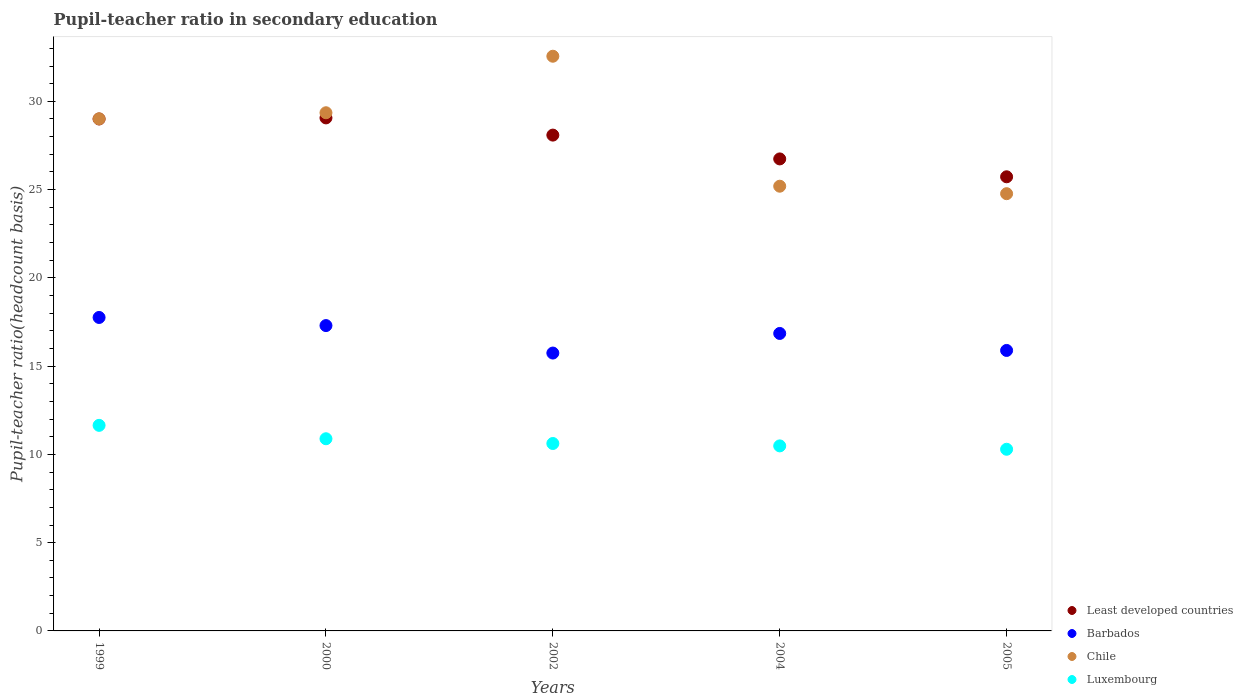How many different coloured dotlines are there?
Make the answer very short. 4. Is the number of dotlines equal to the number of legend labels?
Give a very brief answer. Yes. What is the pupil-teacher ratio in secondary education in Luxembourg in 2005?
Your response must be concise. 10.29. Across all years, what is the maximum pupil-teacher ratio in secondary education in Luxembourg?
Your response must be concise. 11.65. Across all years, what is the minimum pupil-teacher ratio in secondary education in Barbados?
Offer a terse response. 15.74. In which year was the pupil-teacher ratio in secondary education in Chile maximum?
Provide a succinct answer. 2002. In which year was the pupil-teacher ratio in secondary education in Least developed countries minimum?
Keep it short and to the point. 2005. What is the total pupil-teacher ratio in secondary education in Least developed countries in the graph?
Offer a terse response. 138.61. What is the difference between the pupil-teacher ratio in secondary education in Luxembourg in 1999 and that in 2004?
Offer a very short reply. 1.16. What is the difference between the pupil-teacher ratio in secondary education in Chile in 1999 and the pupil-teacher ratio in secondary education in Luxembourg in 2005?
Keep it short and to the point. 18.72. What is the average pupil-teacher ratio in secondary education in Chile per year?
Provide a short and direct response. 28.18. In the year 2002, what is the difference between the pupil-teacher ratio in secondary education in Luxembourg and pupil-teacher ratio in secondary education in Chile?
Provide a short and direct response. -21.94. What is the ratio of the pupil-teacher ratio in secondary education in Chile in 2002 to that in 2005?
Your response must be concise. 1.31. Is the pupil-teacher ratio in secondary education in Least developed countries in 1999 less than that in 2004?
Keep it short and to the point. No. Is the difference between the pupil-teacher ratio in secondary education in Luxembourg in 1999 and 2004 greater than the difference between the pupil-teacher ratio in secondary education in Chile in 1999 and 2004?
Provide a succinct answer. No. What is the difference between the highest and the second highest pupil-teacher ratio in secondary education in Barbados?
Offer a terse response. 0.46. What is the difference between the highest and the lowest pupil-teacher ratio in secondary education in Chile?
Keep it short and to the point. 7.79. In how many years, is the pupil-teacher ratio in secondary education in Luxembourg greater than the average pupil-teacher ratio in secondary education in Luxembourg taken over all years?
Make the answer very short. 2. Is the sum of the pupil-teacher ratio in secondary education in Least developed countries in 1999 and 2004 greater than the maximum pupil-teacher ratio in secondary education in Luxembourg across all years?
Ensure brevity in your answer.  Yes. Is it the case that in every year, the sum of the pupil-teacher ratio in secondary education in Chile and pupil-teacher ratio in secondary education in Barbados  is greater than the sum of pupil-teacher ratio in secondary education in Luxembourg and pupil-teacher ratio in secondary education in Least developed countries?
Make the answer very short. No. Is it the case that in every year, the sum of the pupil-teacher ratio in secondary education in Chile and pupil-teacher ratio in secondary education in Luxembourg  is greater than the pupil-teacher ratio in secondary education in Least developed countries?
Your answer should be very brief. Yes. Does the pupil-teacher ratio in secondary education in Chile monotonically increase over the years?
Your answer should be very brief. No. Is the pupil-teacher ratio in secondary education in Barbados strictly greater than the pupil-teacher ratio in secondary education in Chile over the years?
Provide a succinct answer. No. Is the pupil-teacher ratio in secondary education in Barbados strictly less than the pupil-teacher ratio in secondary education in Least developed countries over the years?
Your answer should be very brief. Yes. How many dotlines are there?
Give a very brief answer. 4. What is the difference between two consecutive major ticks on the Y-axis?
Offer a very short reply. 5. Does the graph contain grids?
Provide a short and direct response. No. Where does the legend appear in the graph?
Your answer should be compact. Bottom right. What is the title of the graph?
Give a very brief answer. Pupil-teacher ratio in secondary education. Does "Chad" appear as one of the legend labels in the graph?
Ensure brevity in your answer.  No. What is the label or title of the Y-axis?
Provide a short and direct response. Pupil-teacher ratio(headcount basis). What is the Pupil-teacher ratio(headcount basis) in Least developed countries in 1999?
Offer a terse response. 29. What is the Pupil-teacher ratio(headcount basis) in Barbados in 1999?
Keep it short and to the point. 17.76. What is the Pupil-teacher ratio(headcount basis) of Chile in 1999?
Your answer should be compact. 29.01. What is the Pupil-teacher ratio(headcount basis) of Luxembourg in 1999?
Offer a terse response. 11.65. What is the Pupil-teacher ratio(headcount basis) of Least developed countries in 2000?
Offer a very short reply. 29.06. What is the Pupil-teacher ratio(headcount basis) in Barbados in 2000?
Your answer should be very brief. 17.3. What is the Pupil-teacher ratio(headcount basis) of Chile in 2000?
Make the answer very short. 29.35. What is the Pupil-teacher ratio(headcount basis) of Luxembourg in 2000?
Your answer should be compact. 10.89. What is the Pupil-teacher ratio(headcount basis) of Least developed countries in 2002?
Give a very brief answer. 28.09. What is the Pupil-teacher ratio(headcount basis) of Barbados in 2002?
Keep it short and to the point. 15.74. What is the Pupil-teacher ratio(headcount basis) in Chile in 2002?
Offer a very short reply. 32.56. What is the Pupil-teacher ratio(headcount basis) of Luxembourg in 2002?
Offer a very short reply. 10.62. What is the Pupil-teacher ratio(headcount basis) of Least developed countries in 2004?
Offer a terse response. 26.74. What is the Pupil-teacher ratio(headcount basis) in Barbados in 2004?
Your response must be concise. 16.85. What is the Pupil-teacher ratio(headcount basis) of Chile in 2004?
Give a very brief answer. 25.19. What is the Pupil-teacher ratio(headcount basis) in Luxembourg in 2004?
Give a very brief answer. 10.48. What is the Pupil-teacher ratio(headcount basis) in Least developed countries in 2005?
Offer a terse response. 25.73. What is the Pupil-teacher ratio(headcount basis) in Barbados in 2005?
Offer a terse response. 15.89. What is the Pupil-teacher ratio(headcount basis) of Chile in 2005?
Offer a very short reply. 24.77. What is the Pupil-teacher ratio(headcount basis) in Luxembourg in 2005?
Your answer should be compact. 10.29. Across all years, what is the maximum Pupil-teacher ratio(headcount basis) of Least developed countries?
Provide a succinct answer. 29.06. Across all years, what is the maximum Pupil-teacher ratio(headcount basis) of Barbados?
Offer a very short reply. 17.76. Across all years, what is the maximum Pupil-teacher ratio(headcount basis) of Chile?
Provide a short and direct response. 32.56. Across all years, what is the maximum Pupil-teacher ratio(headcount basis) of Luxembourg?
Ensure brevity in your answer.  11.65. Across all years, what is the minimum Pupil-teacher ratio(headcount basis) in Least developed countries?
Offer a very short reply. 25.73. Across all years, what is the minimum Pupil-teacher ratio(headcount basis) of Barbados?
Provide a short and direct response. 15.74. Across all years, what is the minimum Pupil-teacher ratio(headcount basis) of Chile?
Ensure brevity in your answer.  24.77. Across all years, what is the minimum Pupil-teacher ratio(headcount basis) in Luxembourg?
Make the answer very short. 10.29. What is the total Pupil-teacher ratio(headcount basis) of Least developed countries in the graph?
Your answer should be compact. 138.61. What is the total Pupil-teacher ratio(headcount basis) in Barbados in the graph?
Give a very brief answer. 83.53. What is the total Pupil-teacher ratio(headcount basis) of Chile in the graph?
Keep it short and to the point. 140.88. What is the total Pupil-teacher ratio(headcount basis) of Luxembourg in the graph?
Provide a short and direct response. 53.92. What is the difference between the Pupil-teacher ratio(headcount basis) of Least developed countries in 1999 and that in 2000?
Offer a very short reply. -0.06. What is the difference between the Pupil-teacher ratio(headcount basis) in Barbados in 1999 and that in 2000?
Your response must be concise. 0.46. What is the difference between the Pupil-teacher ratio(headcount basis) in Chile in 1999 and that in 2000?
Make the answer very short. -0.34. What is the difference between the Pupil-teacher ratio(headcount basis) of Luxembourg in 1999 and that in 2000?
Your response must be concise. 0.76. What is the difference between the Pupil-teacher ratio(headcount basis) of Least developed countries in 1999 and that in 2002?
Your answer should be very brief. 0.91. What is the difference between the Pupil-teacher ratio(headcount basis) in Barbados in 1999 and that in 2002?
Provide a short and direct response. 2.02. What is the difference between the Pupil-teacher ratio(headcount basis) in Chile in 1999 and that in 2002?
Your answer should be very brief. -3.55. What is the difference between the Pupil-teacher ratio(headcount basis) in Luxembourg in 1999 and that in 2002?
Give a very brief answer. 1.03. What is the difference between the Pupil-teacher ratio(headcount basis) of Least developed countries in 1999 and that in 2004?
Your answer should be compact. 2.26. What is the difference between the Pupil-teacher ratio(headcount basis) in Barbados in 1999 and that in 2004?
Keep it short and to the point. 0.91. What is the difference between the Pupil-teacher ratio(headcount basis) of Chile in 1999 and that in 2004?
Make the answer very short. 3.82. What is the difference between the Pupil-teacher ratio(headcount basis) of Luxembourg in 1999 and that in 2004?
Ensure brevity in your answer.  1.16. What is the difference between the Pupil-teacher ratio(headcount basis) in Least developed countries in 1999 and that in 2005?
Your answer should be very brief. 3.28. What is the difference between the Pupil-teacher ratio(headcount basis) in Barbados in 1999 and that in 2005?
Your answer should be very brief. 1.87. What is the difference between the Pupil-teacher ratio(headcount basis) of Chile in 1999 and that in 2005?
Your response must be concise. 4.24. What is the difference between the Pupil-teacher ratio(headcount basis) of Luxembourg in 1999 and that in 2005?
Keep it short and to the point. 1.35. What is the difference between the Pupil-teacher ratio(headcount basis) in Least developed countries in 2000 and that in 2002?
Give a very brief answer. 0.97. What is the difference between the Pupil-teacher ratio(headcount basis) of Barbados in 2000 and that in 2002?
Offer a terse response. 1.56. What is the difference between the Pupil-teacher ratio(headcount basis) in Chile in 2000 and that in 2002?
Keep it short and to the point. -3.2. What is the difference between the Pupil-teacher ratio(headcount basis) of Luxembourg in 2000 and that in 2002?
Ensure brevity in your answer.  0.27. What is the difference between the Pupil-teacher ratio(headcount basis) of Least developed countries in 2000 and that in 2004?
Offer a very short reply. 2.32. What is the difference between the Pupil-teacher ratio(headcount basis) in Barbados in 2000 and that in 2004?
Your answer should be compact. 0.45. What is the difference between the Pupil-teacher ratio(headcount basis) in Chile in 2000 and that in 2004?
Ensure brevity in your answer.  4.16. What is the difference between the Pupil-teacher ratio(headcount basis) in Luxembourg in 2000 and that in 2004?
Give a very brief answer. 0.4. What is the difference between the Pupil-teacher ratio(headcount basis) of Least developed countries in 2000 and that in 2005?
Your response must be concise. 3.34. What is the difference between the Pupil-teacher ratio(headcount basis) of Barbados in 2000 and that in 2005?
Your response must be concise. 1.41. What is the difference between the Pupil-teacher ratio(headcount basis) of Chile in 2000 and that in 2005?
Ensure brevity in your answer.  4.58. What is the difference between the Pupil-teacher ratio(headcount basis) of Luxembourg in 2000 and that in 2005?
Make the answer very short. 0.6. What is the difference between the Pupil-teacher ratio(headcount basis) of Least developed countries in 2002 and that in 2004?
Ensure brevity in your answer.  1.35. What is the difference between the Pupil-teacher ratio(headcount basis) in Barbados in 2002 and that in 2004?
Your response must be concise. -1.11. What is the difference between the Pupil-teacher ratio(headcount basis) of Chile in 2002 and that in 2004?
Ensure brevity in your answer.  7.36. What is the difference between the Pupil-teacher ratio(headcount basis) in Luxembourg in 2002 and that in 2004?
Your response must be concise. 0.14. What is the difference between the Pupil-teacher ratio(headcount basis) of Least developed countries in 2002 and that in 2005?
Ensure brevity in your answer.  2.36. What is the difference between the Pupil-teacher ratio(headcount basis) of Barbados in 2002 and that in 2005?
Your answer should be very brief. -0.15. What is the difference between the Pupil-teacher ratio(headcount basis) of Chile in 2002 and that in 2005?
Your answer should be compact. 7.79. What is the difference between the Pupil-teacher ratio(headcount basis) in Luxembourg in 2002 and that in 2005?
Make the answer very short. 0.33. What is the difference between the Pupil-teacher ratio(headcount basis) in Least developed countries in 2004 and that in 2005?
Offer a terse response. 1.01. What is the difference between the Pupil-teacher ratio(headcount basis) of Barbados in 2004 and that in 2005?
Your answer should be compact. 0.96. What is the difference between the Pupil-teacher ratio(headcount basis) of Chile in 2004 and that in 2005?
Make the answer very short. 0.42. What is the difference between the Pupil-teacher ratio(headcount basis) in Luxembourg in 2004 and that in 2005?
Your answer should be compact. 0.19. What is the difference between the Pupil-teacher ratio(headcount basis) in Least developed countries in 1999 and the Pupil-teacher ratio(headcount basis) in Barbados in 2000?
Offer a very short reply. 11.7. What is the difference between the Pupil-teacher ratio(headcount basis) in Least developed countries in 1999 and the Pupil-teacher ratio(headcount basis) in Chile in 2000?
Your answer should be compact. -0.35. What is the difference between the Pupil-teacher ratio(headcount basis) of Least developed countries in 1999 and the Pupil-teacher ratio(headcount basis) of Luxembourg in 2000?
Provide a succinct answer. 18.11. What is the difference between the Pupil-teacher ratio(headcount basis) in Barbados in 1999 and the Pupil-teacher ratio(headcount basis) in Chile in 2000?
Keep it short and to the point. -11.6. What is the difference between the Pupil-teacher ratio(headcount basis) in Barbados in 1999 and the Pupil-teacher ratio(headcount basis) in Luxembourg in 2000?
Your answer should be compact. 6.87. What is the difference between the Pupil-teacher ratio(headcount basis) in Chile in 1999 and the Pupil-teacher ratio(headcount basis) in Luxembourg in 2000?
Offer a terse response. 18.12. What is the difference between the Pupil-teacher ratio(headcount basis) in Least developed countries in 1999 and the Pupil-teacher ratio(headcount basis) in Barbados in 2002?
Ensure brevity in your answer.  13.26. What is the difference between the Pupil-teacher ratio(headcount basis) in Least developed countries in 1999 and the Pupil-teacher ratio(headcount basis) in Chile in 2002?
Your answer should be compact. -3.55. What is the difference between the Pupil-teacher ratio(headcount basis) in Least developed countries in 1999 and the Pupil-teacher ratio(headcount basis) in Luxembourg in 2002?
Ensure brevity in your answer.  18.38. What is the difference between the Pupil-teacher ratio(headcount basis) of Barbados in 1999 and the Pupil-teacher ratio(headcount basis) of Chile in 2002?
Your answer should be compact. -14.8. What is the difference between the Pupil-teacher ratio(headcount basis) of Barbados in 1999 and the Pupil-teacher ratio(headcount basis) of Luxembourg in 2002?
Provide a short and direct response. 7.14. What is the difference between the Pupil-teacher ratio(headcount basis) of Chile in 1999 and the Pupil-teacher ratio(headcount basis) of Luxembourg in 2002?
Your answer should be compact. 18.39. What is the difference between the Pupil-teacher ratio(headcount basis) of Least developed countries in 1999 and the Pupil-teacher ratio(headcount basis) of Barbados in 2004?
Your answer should be compact. 12.15. What is the difference between the Pupil-teacher ratio(headcount basis) in Least developed countries in 1999 and the Pupil-teacher ratio(headcount basis) in Chile in 2004?
Keep it short and to the point. 3.81. What is the difference between the Pupil-teacher ratio(headcount basis) of Least developed countries in 1999 and the Pupil-teacher ratio(headcount basis) of Luxembourg in 2004?
Keep it short and to the point. 18.52. What is the difference between the Pupil-teacher ratio(headcount basis) in Barbados in 1999 and the Pupil-teacher ratio(headcount basis) in Chile in 2004?
Your answer should be compact. -7.44. What is the difference between the Pupil-teacher ratio(headcount basis) in Barbados in 1999 and the Pupil-teacher ratio(headcount basis) in Luxembourg in 2004?
Your response must be concise. 7.28. What is the difference between the Pupil-teacher ratio(headcount basis) in Chile in 1999 and the Pupil-teacher ratio(headcount basis) in Luxembourg in 2004?
Ensure brevity in your answer.  18.53. What is the difference between the Pupil-teacher ratio(headcount basis) in Least developed countries in 1999 and the Pupil-teacher ratio(headcount basis) in Barbados in 2005?
Your answer should be very brief. 13.11. What is the difference between the Pupil-teacher ratio(headcount basis) of Least developed countries in 1999 and the Pupil-teacher ratio(headcount basis) of Chile in 2005?
Offer a very short reply. 4.23. What is the difference between the Pupil-teacher ratio(headcount basis) of Least developed countries in 1999 and the Pupil-teacher ratio(headcount basis) of Luxembourg in 2005?
Your response must be concise. 18.71. What is the difference between the Pupil-teacher ratio(headcount basis) in Barbados in 1999 and the Pupil-teacher ratio(headcount basis) in Chile in 2005?
Your response must be concise. -7.01. What is the difference between the Pupil-teacher ratio(headcount basis) in Barbados in 1999 and the Pupil-teacher ratio(headcount basis) in Luxembourg in 2005?
Offer a terse response. 7.47. What is the difference between the Pupil-teacher ratio(headcount basis) of Chile in 1999 and the Pupil-teacher ratio(headcount basis) of Luxembourg in 2005?
Keep it short and to the point. 18.72. What is the difference between the Pupil-teacher ratio(headcount basis) of Least developed countries in 2000 and the Pupil-teacher ratio(headcount basis) of Barbados in 2002?
Ensure brevity in your answer.  13.32. What is the difference between the Pupil-teacher ratio(headcount basis) of Least developed countries in 2000 and the Pupil-teacher ratio(headcount basis) of Chile in 2002?
Offer a terse response. -3.49. What is the difference between the Pupil-teacher ratio(headcount basis) in Least developed countries in 2000 and the Pupil-teacher ratio(headcount basis) in Luxembourg in 2002?
Offer a terse response. 18.44. What is the difference between the Pupil-teacher ratio(headcount basis) in Barbados in 2000 and the Pupil-teacher ratio(headcount basis) in Chile in 2002?
Your answer should be compact. -15.26. What is the difference between the Pupil-teacher ratio(headcount basis) of Barbados in 2000 and the Pupil-teacher ratio(headcount basis) of Luxembourg in 2002?
Provide a succinct answer. 6.68. What is the difference between the Pupil-teacher ratio(headcount basis) of Chile in 2000 and the Pupil-teacher ratio(headcount basis) of Luxembourg in 2002?
Give a very brief answer. 18.74. What is the difference between the Pupil-teacher ratio(headcount basis) in Least developed countries in 2000 and the Pupil-teacher ratio(headcount basis) in Barbados in 2004?
Your answer should be very brief. 12.21. What is the difference between the Pupil-teacher ratio(headcount basis) in Least developed countries in 2000 and the Pupil-teacher ratio(headcount basis) in Chile in 2004?
Give a very brief answer. 3.87. What is the difference between the Pupil-teacher ratio(headcount basis) of Least developed countries in 2000 and the Pupil-teacher ratio(headcount basis) of Luxembourg in 2004?
Offer a terse response. 18.58. What is the difference between the Pupil-teacher ratio(headcount basis) in Barbados in 2000 and the Pupil-teacher ratio(headcount basis) in Chile in 2004?
Ensure brevity in your answer.  -7.9. What is the difference between the Pupil-teacher ratio(headcount basis) of Barbados in 2000 and the Pupil-teacher ratio(headcount basis) of Luxembourg in 2004?
Provide a succinct answer. 6.82. What is the difference between the Pupil-teacher ratio(headcount basis) of Chile in 2000 and the Pupil-teacher ratio(headcount basis) of Luxembourg in 2004?
Ensure brevity in your answer.  18.87. What is the difference between the Pupil-teacher ratio(headcount basis) of Least developed countries in 2000 and the Pupil-teacher ratio(headcount basis) of Barbados in 2005?
Make the answer very short. 13.17. What is the difference between the Pupil-teacher ratio(headcount basis) in Least developed countries in 2000 and the Pupil-teacher ratio(headcount basis) in Chile in 2005?
Offer a terse response. 4.29. What is the difference between the Pupil-teacher ratio(headcount basis) in Least developed countries in 2000 and the Pupil-teacher ratio(headcount basis) in Luxembourg in 2005?
Keep it short and to the point. 18.77. What is the difference between the Pupil-teacher ratio(headcount basis) in Barbados in 2000 and the Pupil-teacher ratio(headcount basis) in Chile in 2005?
Your answer should be compact. -7.47. What is the difference between the Pupil-teacher ratio(headcount basis) in Barbados in 2000 and the Pupil-teacher ratio(headcount basis) in Luxembourg in 2005?
Ensure brevity in your answer.  7.01. What is the difference between the Pupil-teacher ratio(headcount basis) in Chile in 2000 and the Pupil-teacher ratio(headcount basis) in Luxembourg in 2005?
Give a very brief answer. 19.06. What is the difference between the Pupil-teacher ratio(headcount basis) in Least developed countries in 2002 and the Pupil-teacher ratio(headcount basis) in Barbados in 2004?
Your answer should be very brief. 11.24. What is the difference between the Pupil-teacher ratio(headcount basis) in Least developed countries in 2002 and the Pupil-teacher ratio(headcount basis) in Chile in 2004?
Provide a short and direct response. 2.89. What is the difference between the Pupil-teacher ratio(headcount basis) in Least developed countries in 2002 and the Pupil-teacher ratio(headcount basis) in Luxembourg in 2004?
Offer a terse response. 17.61. What is the difference between the Pupil-teacher ratio(headcount basis) in Barbados in 2002 and the Pupil-teacher ratio(headcount basis) in Chile in 2004?
Ensure brevity in your answer.  -9.45. What is the difference between the Pupil-teacher ratio(headcount basis) of Barbados in 2002 and the Pupil-teacher ratio(headcount basis) of Luxembourg in 2004?
Keep it short and to the point. 5.26. What is the difference between the Pupil-teacher ratio(headcount basis) of Chile in 2002 and the Pupil-teacher ratio(headcount basis) of Luxembourg in 2004?
Your answer should be compact. 22.07. What is the difference between the Pupil-teacher ratio(headcount basis) in Least developed countries in 2002 and the Pupil-teacher ratio(headcount basis) in Barbados in 2005?
Your answer should be compact. 12.2. What is the difference between the Pupil-teacher ratio(headcount basis) of Least developed countries in 2002 and the Pupil-teacher ratio(headcount basis) of Chile in 2005?
Your answer should be compact. 3.32. What is the difference between the Pupil-teacher ratio(headcount basis) in Least developed countries in 2002 and the Pupil-teacher ratio(headcount basis) in Luxembourg in 2005?
Offer a very short reply. 17.8. What is the difference between the Pupil-teacher ratio(headcount basis) of Barbados in 2002 and the Pupil-teacher ratio(headcount basis) of Chile in 2005?
Make the answer very short. -9.03. What is the difference between the Pupil-teacher ratio(headcount basis) in Barbados in 2002 and the Pupil-teacher ratio(headcount basis) in Luxembourg in 2005?
Ensure brevity in your answer.  5.45. What is the difference between the Pupil-teacher ratio(headcount basis) in Chile in 2002 and the Pupil-teacher ratio(headcount basis) in Luxembourg in 2005?
Provide a succinct answer. 22.26. What is the difference between the Pupil-teacher ratio(headcount basis) of Least developed countries in 2004 and the Pupil-teacher ratio(headcount basis) of Barbados in 2005?
Keep it short and to the point. 10.85. What is the difference between the Pupil-teacher ratio(headcount basis) in Least developed countries in 2004 and the Pupil-teacher ratio(headcount basis) in Chile in 2005?
Your response must be concise. 1.97. What is the difference between the Pupil-teacher ratio(headcount basis) of Least developed countries in 2004 and the Pupil-teacher ratio(headcount basis) of Luxembourg in 2005?
Ensure brevity in your answer.  16.45. What is the difference between the Pupil-teacher ratio(headcount basis) in Barbados in 2004 and the Pupil-teacher ratio(headcount basis) in Chile in 2005?
Your response must be concise. -7.92. What is the difference between the Pupil-teacher ratio(headcount basis) of Barbados in 2004 and the Pupil-teacher ratio(headcount basis) of Luxembourg in 2005?
Offer a very short reply. 6.56. What is the difference between the Pupil-teacher ratio(headcount basis) in Chile in 2004 and the Pupil-teacher ratio(headcount basis) in Luxembourg in 2005?
Offer a terse response. 14.9. What is the average Pupil-teacher ratio(headcount basis) in Least developed countries per year?
Provide a short and direct response. 27.72. What is the average Pupil-teacher ratio(headcount basis) of Barbados per year?
Provide a succinct answer. 16.71. What is the average Pupil-teacher ratio(headcount basis) of Chile per year?
Offer a very short reply. 28.18. What is the average Pupil-teacher ratio(headcount basis) in Luxembourg per year?
Keep it short and to the point. 10.78. In the year 1999, what is the difference between the Pupil-teacher ratio(headcount basis) in Least developed countries and Pupil-teacher ratio(headcount basis) in Barbados?
Give a very brief answer. 11.24. In the year 1999, what is the difference between the Pupil-teacher ratio(headcount basis) of Least developed countries and Pupil-teacher ratio(headcount basis) of Chile?
Your response must be concise. -0.01. In the year 1999, what is the difference between the Pupil-teacher ratio(headcount basis) of Least developed countries and Pupil-teacher ratio(headcount basis) of Luxembourg?
Your answer should be very brief. 17.36. In the year 1999, what is the difference between the Pupil-teacher ratio(headcount basis) in Barbados and Pupil-teacher ratio(headcount basis) in Chile?
Your answer should be compact. -11.25. In the year 1999, what is the difference between the Pupil-teacher ratio(headcount basis) in Barbados and Pupil-teacher ratio(headcount basis) in Luxembourg?
Your answer should be compact. 6.11. In the year 1999, what is the difference between the Pupil-teacher ratio(headcount basis) of Chile and Pupil-teacher ratio(headcount basis) of Luxembourg?
Ensure brevity in your answer.  17.36. In the year 2000, what is the difference between the Pupil-teacher ratio(headcount basis) of Least developed countries and Pupil-teacher ratio(headcount basis) of Barbados?
Offer a very short reply. 11.76. In the year 2000, what is the difference between the Pupil-teacher ratio(headcount basis) in Least developed countries and Pupil-teacher ratio(headcount basis) in Chile?
Your answer should be compact. -0.29. In the year 2000, what is the difference between the Pupil-teacher ratio(headcount basis) of Least developed countries and Pupil-teacher ratio(headcount basis) of Luxembourg?
Keep it short and to the point. 18.18. In the year 2000, what is the difference between the Pupil-teacher ratio(headcount basis) of Barbados and Pupil-teacher ratio(headcount basis) of Chile?
Provide a succinct answer. -12.06. In the year 2000, what is the difference between the Pupil-teacher ratio(headcount basis) of Barbados and Pupil-teacher ratio(headcount basis) of Luxembourg?
Your answer should be very brief. 6.41. In the year 2000, what is the difference between the Pupil-teacher ratio(headcount basis) of Chile and Pupil-teacher ratio(headcount basis) of Luxembourg?
Your answer should be very brief. 18.47. In the year 2002, what is the difference between the Pupil-teacher ratio(headcount basis) of Least developed countries and Pupil-teacher ratio(headcount basis) of Barbados?
Keep it short and to the point. 12.35. In the year 2002, what is the difference between the Pupil-teacher ratio(headcount basis) in Least developed countries and Pupil-teacher ratio(headcount basis) in Chile?
Provide a succinct answer. -4.47. In the year 2002, what is the difference between the Pupil-teacher ratio(headcount basis) of Least developed countries and Pupil-teacher ratio(headcount basis) of Luxembourg?
Provide a short and direct response. 17.47. In the year 2002, what is the difference between the Pupil-teacher ratio(headcount basis) in Barbados and Pupil-teacher ratio(headcount basis) in Chile?
Offer a terse response. -16.82. In the year 2002, what is the difference between the Pupil-teacher ratio(headcount basis) in Barbados and Pupil-teacher ratio(headcount basis) in Luxembourg?
Keep it short and to the point. 5.12. In the year 2002, what is the difference between the Pupil-teacher ratio(headcount basis) in Chile and Pupil-teacher ratio(headcount basis) in Luxembourg?
Keep it short and to the point. 21.94. In the year 2004, what is the difference between the Pupil-teacher ratio(headcount basis) in Least developed countries and Pupil-teacher ratio(headcount basis) in Barbados?
Your answer should be compact. 9.89. In the year 2004, what is the difference between the Pupil-teacher ratio(headcount basis) in Least developed countries and Pupil-teacher ratio(headcount basis) in Chile?
Your answer should be compact. 1.55. In the year 2004, what is the difference between the Pupil-teacher ratio(headcount basis) of Least developed countries and Pupil-teacher ratio(headcount basis) of Luxembourg?
Your answer should be compact. 16.26. In the year 2004, what is the difference between the Pupil-teacher ratio(headcount basis) in Barbados and Pupil-teacher ratio(headcount basis) in Chile?
Offer a terse response. -8.34. In the year 2004, what is the difference between the Pupil-teacher ratio(headcount basis) of Barbados and Pupil-teacher ratio(headcount basis) of Luxembourg?
Your answer should be compact. 6.37. In the year 2004, what is the difference between the Pupil-teacher ratio(headcount basis) in Chile and Pupil-teacher ratio(headcount basis) in Luxembourg?
Keep it short and to the point. 14.71. In the year 2005, what is the difference between the Pupil-teacher ratio(headcount basis) in Least developed countries and Pupil-teacher ratio(headcount basis) in Barbados?
Provide a short and direct response. 9.84. In the year 2005, what is the difference between the Pupil-teacher ratio(headcount basis) of Least developed countries and Pupil-teacher ratio(headcount basis) of Luxembourg?
Ensure brevity in your answer.  15.43. In the year 2005, what is the difference between the Pupil-teacher ratio(headcount basis) of Barbados and Pupil-teacher ratio(headcount basis) of Chile?
Your answer should be compact. -8.88. In the year 2005, what is the difference between the Pupil-teacher ratio(headcount basis) of Barbados and Pupil-teacher ratio(headcount basis) of Luxembourg?
Give a very brief answer. 5.6. In the year 2005, what is the difference between the Pupil-teacher ratio(headcount basis) in Chile and Pupil-teacher ratio(headcount basis) in Luxembourg?
Ensure brevity in your answer.  14.48. What is the ratio of the Pupil-teacher ratio(headcount basis) in Least developed countries in 1999 to that in 2000?
Give a very brief answer. 1. What is the ratio of the Pupil-teacher ratio(headcount basis) of Barbados in 1999 to that in 2000?
Keep it short and to the point. 1.03. What is the ratio of the Pupil-teacher ratio(headcount basis) in Chile in 1999 to that in 2000?
Give a very brief answer. 0.99. What is the ratio of the Pupil-teacher ratio(headcount basis) of Luxembourg in 1999 to that in 2000?
Offer a very short reply. 1.07. What is the ratio of the Pupil-teacher ratio(headcount basis) of Least developed countries in 1999 to that in 2002?
Your answer should be very brief. 1.03. What is the ratio of the Pupil-teacher ratio(headcount basis) in Barbados in 1999 to that in 2002?
Offer a terse response. 1.13. What is the ratio of the Pupil-teacher ratio(headcount basis) of Chile in 1999 to that in 2002?
Make the answer very short. 0.89. What is the ratio of the Pupil-teacher ratio(headcount basis) of Luxembourg in 1999 to that in 2002?
Give a very brief answer. 1.1. What is the ratio of the Pupil-teacher ratio(headcount basis) of Least developed countries in 1999 to that in 2004?
Offer a very short reply. 1.08. What is the ratio of the Pupil-teacher ratio(headcount basis) in Barbados in 1999 to that in 2004?
Offer a terse response. 1.05. What is the ratio of the Pupil-teacher ratio(headcount basis) of Chile in 1999 to that in 2004?
Offer a very short reply. 1.15. What is the ratio of the Pupil-teacher ratio(headcount basis) of Luxembourg in 1999 to that in 2004?
Offer a very short reply. 1.11. What is the ratio of the Pupil-teacher ratio(headcount basis) in Least developed countries in 1999 to that in 2005?
Give a very brief answer. 1.13. What is the ratio of the Pupil-teacher ratio(headcount basis) in Barbados in 1999 to that in 2005?
Keep it short and to the point. 1.12. What is the ratio of the Pupil-teacher ratio(headcount basis) of Chile in 1999 to that in 2005?
Make the answer very short. 1.17. What is the ratio of the Pupil-teacher ratio(headcount basis) in Luxembourg in 1999 to that in 2005?
Ensure brevity in your answer.  1.13. What is the ratio of the Pupil-teacher ratio(headcount basis) of Least developed countries in 2000 to that in 2002?
Make the answer very short. 1.03. What is the ratio of the Pupil-teacher ratio(headcount basis) in Barbados in 2000 to that in 2002?
Give a very brief answer. 1.1. What is the ratio of the Pupil-teacher ratio(headcount basis) in Chile in 2000 to that in 2002?
Ensure brevity in your answer.  0.9. What is the ratio of the Pupil-teacher ratio(headcount basis) of Luxembourg in 2000 to that in 2002?
Provide a short and direct response. 1.03. What is the ratio of the Pupil-teacher ratio(headcount basis) in Least developed countries in 2000 to that in 2004?
Keep it short and to the point. 1.09. What is the ratio of the Pupil-teacher ratio(headcount basis) in Barbados in 2000 to that in 2004?
Provide a short and direct response. 1.03. What is the ratio of the Pupil-teacher ratio(headcount basis) of Chile in 2000 to that in 2004?
Give a very brief answer. 1.17. What is the ratio of the Pupil-teacher ratio(headcount basis) of Luxembourg in 2000 to that in 2004?
Your response must be concise. 1.04. What is the ratio of the Pupil-teacher ratio(headcount basis) of Least developed countries in 2000 to that in 2005?
Your answer should be compact. 1.13. What is the ratio of the Pupil-teacher ratio(headcount basis) of Barbados in 2000 to that in 2005?
Provide a succinct answer. 1.09. What is the ratio of the Pupil-teacher ratio(headcount basis) in Chile in 2000 to that in 2005?
Provide a short and direct response. 1.19. What is the ratio of the Pupil-teacher ratio(headcount basis) in Luxembourg in 2000 to that in 2005?
Your answer should be compact. 1.06. What is the ratio of the Pupil-teacher ratio(headcount basis) in Least developed countries in 2002 to that in 2004?
Make the answer very short. 1.05. What is the ratio of the Pupil-teacher ratio(headcount basis) of Barbados in 2002 to that in 2004?
Your response must be concise. 0.93. What is the ratio of the Pupil-teacher ratio(headcount basis) in Chile in 2002 to that in 2004?
Offer a terse response. 1.29. What is the ratio of the Pupil-teacher ratio(headcount basis) of Luxembourg in 2002 to that in 2004?
Give a very brief answer. 1.01. What is the ratio of the Pupil-teacher ratio(headcount basis) in Least developed countries in 2002 to that in 2005?
Ensure brevity in your answer.  1.09. What is the ratio of the Pupil-teacher ratio(headcount basis) in Chile in 2002 to that in 2005?
Your answer should be compact. 1.31. What is the ratio of the Pupil-teacher ratio(headcount basis) of Luxembourg in 2002 to that in 2005?
Your answer should be compact. 1.03. What is the ratio of the Pupil-teacher ratio(headcount basis) of Least developed countries in 2004 to that in 2005?
Give a very brief answer. 1.04. What is the ratio of the Pupil-teacher ratio(headcount basis) in Barbados in 2004 to that in 2005?
Your answer should be compact. 1.06. What is the ratio of the Pupil-teacher ratio(headcount basis) of Chile in 2004 to that in 2005?
Make the answer very short. 1.02. What is the ratio of the Pupil-teacher ratio(headcount basis) in Luxembourg in 2004 to that in 2005?
Your response must be concise. 1.02. What is the difference between the highest and the second highest Pupil-teacher ratio(headcount basis) of Least developed countries?
Ensure brevity in your answer.  0.06. What is the difference between the highest and the second highest Pupil-teacher ratio(headcount basis) in Barbados?
Provide a short and direct response. 0.46. What is the difference between the highest and the second highest Pupil-teacher ratio(headcount basis) of Chile?
Make the answer very short. 3.2. What is the difference between the highest and the second highest Pupil-teacher ratio(headcount basis) of Luxembourg?
Your answer should be very brief. 0.76. What is the difference between the highest and the lowest Pupil-teacher ratio(headcount basis) in Least developed countries?
Your response must be concise. 3.34. What is the difference between the highest and the lowest Pupil-teacher ratio(headcount basis) of Barbados?
Your answer should be compact. 2.02. What is the difference between the highest and the lowest Pupil-teacher ratio(headcount basis) of Chile?
Provide a short and direct response. 7.79. What is the difference between the highest and the lowest Pupil-teacher ratio(headcount basis) in Luxembourg?
Your answer should be compact. 1.35. 